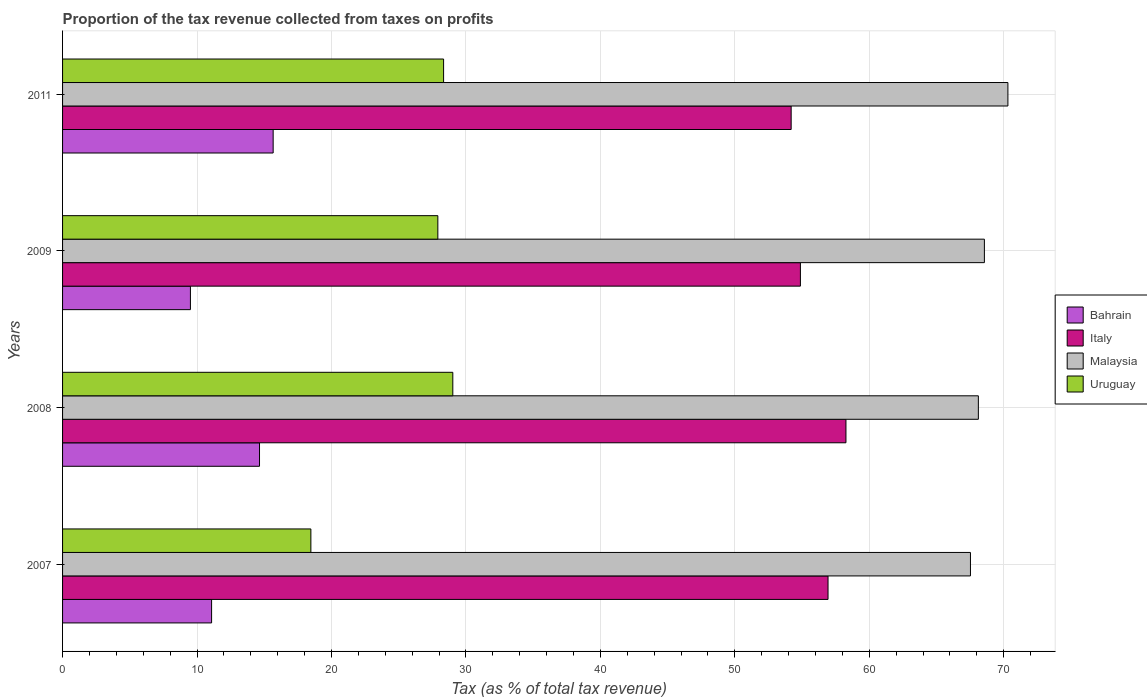How many different coloured bars are there?
Offer a very short reply. 4. What is the label of the 3rd group of bars from the top?
Offer a terse response. 2008. In how many cases, is the number of bars for a given year not equal to the number of legend labels?
Provide a short and direct response. 0. What is the proportion of the tax revenue collected in Italy in 2011?
Offer a very short reply. 54.19. Across all years, what is the maximum proportion of the tax revenue collected in Malaysia?
Offer a terse response. 70.31. Across all years, what is the minimum proportion of the tax revenue collected in Uruguay?
Your response must be concise. 18.47. In which year was the proportion of the tax revenue collected in Italy maximum?
Ensure brevity in your answer.  2008. What is the total proportion of the tax revenue collected in Uruguay in the graph?
Keep it short and to the point. 103.74. What is the difference between the proportion of the tax revenue collected in Bahrain in 2007 and that in 2011?
Your answer should be compact. -4.58. What is the difference between the proportion of the tax revenue collected in Bahrain in 2011 and the proportion of the tax revenue collected in Italy in 2007?
Make the answer very short. -41.27. What is the average proportion of the tax revenue collected in Uruguay per year?
Provide a short and direct response. 25.94. In the year 2011, what is the difference between the proportion of the tax revenue collected in Uruguay and proportion of the tax revenue collected in Bahrain?
Give a very brief answer. 12.68. In how many years, is the proportion of the tax revenue collected in Uruguay greater than 16 %?
Your response must be concise. 4. What is the ratio of the proportion of the tax revenue collected in Italy in 2008 to that in 2009?
Keep it short and to the point. 1.06. Is the difference between the proportion of the tax revenue collected in Uruguay in 2007 and 2011 greater than the difference between the proportion of the tax revenue collected in Bahrain in 2007 and 2011?
Make the answer very short. No. What is the difference between the highest and the second highest proportion of the tax revenue collected in Malaysia?
Your response must be concise. 1.75. What is the difference between the highest and the lowest proportion of the tax revenue collected in Malaysia?
Your response must be concise. 2.79. What does the 2nd bar from the top in 2007 represents?
Provide a succinct answer. Malaysia. What does the 1st bar from the bottom in 2009 represents?
Your answer should be compact. Bahrain. Are all the bars in the graph horizontal?
Provide a short and direct response. Yes. How many years are there in the graph?
Offer a very short reply. 4. Does the graph contain any zero values?
Your answer should be very brief. No. Where does the legend appear in the graph?
Offer a terse response. Center right. How many legend labels are there?
Offer a terse response. 4. What is the title of the graph?
Offer a terse response. Proportion of the tax revenue collected from taxes on profits. What is the label or title of the X-axis?
Provide a succinct answer. Tax (as % of total tax revenue). What is the Tax (as % of total tax revenue) in Bahrain in 2007?
Your answer should be compact. 11.08. What is the Tax (as % of total tax revenue) in Italy in 2007?
Your answer should be compact. 56.93. What is the Tax (as % of total tax revenue) of Malaysia in 2007?
Offer a very short reply. 67.53. What is the Tax (as % of total tax revenue) of Uruguay in 2007?
Keep it short and to the point. 18.47. What is the Tax (as % of total tax revenue) of Bahrain in 2008?
Ensure brevity in your answer.  14.65. What is the Tax (as % of total tax revenue) in Italy in 2008?
Your response must be concise. 58.27. What is the Tax (as % of total tax revenue) in Malaysia in 2008?
Your answer should be very brief. 68.11. What is the Tax (as % of total tax revenue) of Uruguay in 2008?
Keep it short and to the point. 29.02. What is the Tax (as % of total tax revenue) of Bahrain in 2009?
Your response must be concise. 9.51. What is the Tax (as % of total tax revenue) in Italy in 2009?
Give a very brief answer. 54.88. What is the Tax (as % of total tax revenue) in Malaysia in 2009?
Your answer should be very brief. 68.56. What is the Tax (as % of total tax revenue) in Uruguay in 2009?
Provide a succinct answer. 27.91. What is the Tax (as % of total tax revenue) of Bahrain in 2011?
Your answer should be compact. 15.66. What is the Tax (as % of total tax revenue) in Italy in 2011?
Keep it short and to the point. 54.19. What is the Tax (as % of total tax revenue) of Malaysia in 2011?
Offer a terse response. 70.31. What is the Tax (as % of total tax revenue) of Uruguay in 2011?
Make the answer very short. 28.34. Across all years, what is the maximum Tax (as % of total tax revenue) in Bahrain?
Your answer should be compact. 15.66. Across all years, what is the maximum Tax (as % of total tax revenue) in Italy?
Provide a succinct answer. 58.27. Across all years, what is the maximum Tax (as % of total tax revenue) of Malaysia?
Provide a succinct answer. 70.31. Across all years, what is the maximum Tax (as % of total tax revenue) of Uruguay?
Offer a very short reply. 29.02. Across all years, what is the minimum Tax (as % of total tax revenue) of Bahrain?
Your answer should be compact. 9.51. Across all years, what is the minimum Tax (as % of total tax revenue) in Italy?
Give a very brief answer. 54.19. Across all years, what is the minimum Tax (as % of total tax revenue) in Malaysia?
Provide a short and direct response. 67.53. Across all years, what is the minimum Tax (as % of total tax revenue) of Uruguay?
Give a very brief answer. 18.47. What is the total Tax (as % of total tax revenue) in Bahrain in the graph?
Your answer should be very brief. 50.9. What is the total Tax (as % of total tax revenue) of Italy in the graph?
Keep it short and to the point. 224.26. What is the total Tax (as % of total tax revenue) of Malaysia in the graph?
Offer a terse response. 274.51. What is the total Tax (as % of total tax revenue) of Uruguay in the graph?
Make the answer very short. 103.74. What is the difference between the Tax (as % of total tax revenue) in Bahrain in 2007 and that in 2008?
Your answer should be very brief. -3.56. What is the difference between the Tax (as % of total tax revenue) of Italy in 2007 and that in 2008?
Make the answer very short. -1.33. What is the difference between the Tax (as % of total tax revenue) of Malaysia in 2007 and that in 2008?
Provide a succinct answer. -0.59. What is the difference between the Tax (as % of total tax revenue) in Uruguay in 2007 and that in 2008?
Ensure brevity in your answer.  -10.56. What is the difference between the Tax (as % of total tax revenue) of Bahrain in 2007 and that in 2009?
Your answer should be very brief. 1.57. What is the difference between the Tax (as % of total tax revenue) in Italy in 2007 and that in 2009?
Give a very brief answer. 2.05. What is the difference between the Tax (as % of total tax revenue) of Malaysia in 2007 and that in 2009?
Provide a succinct answer. -1.04. What is the difference between the Tax (as % of total tax revenue) in Uruguay in 2007 and that in 2009?
Give a very brief answer. -9.44. What is the difference between the Tax (as % of total tax revenue) in Bahrain in 2007 and that in 2011?
Make the answer very short. -4.58. What is the difference between the Tax (as % of total tax revenue) of Italy in 2007 and that in 2011?
Provide a succinct answer. 2.74. What is the difference between the Tax (as % of total tax revenue) in Malaysia in 2007 and that in 2011?
Offer a very short reply. -2.79. What is the difference between the Tax (as % of total tax revenue) in Uruguay in 2007 and that in 2011?
Provide a short and direct response. -9.87. What is the difference between the Tax (as % of total tax revenue) of Bahrain in 2008 and that in 2009?
Keep it short and to the point. 5.14. What is the difference between the Tax (as % of total tax revenue) in Italy in 2008 and that in 2009?
Offer a very short reply. 3.39. What is the difference between the Tax (as % of total tax revenue) of Malaysia in 2008 and that in 2009?
Keep it short and to the point. -0.45. What is the difference between the Tax (as % of total tax revenue) of Uruguay in 2008 and that in 2009?
Give a very brief answer. 1.11. What is the difference between the Tax (as % of total tax revenue) of Bahrain in 2008 and that in 2011?
Offer a very short reply. -1.01. What is the difference between the Tax (as % of total tax revenue) of Italy in 2008 and that in 2011?
Ensure brevity in your answer.  4.08. What is the difference between the Tax (as % of total tax revenue) in Malaysia in 2008 and that in 2011?
Make the answer very short. -2.2. What is the difference between the Tax (as % of total tax revenue) of Uruguay in 2008 and that in 2011?
Keep it short and to the point. 0.69. What is the difference between the Tax (as % of total tax revenue) of Bahrain in 2009 and that in 2011?
Offer a terse response. -6.15. What is the difference between the Tax (as % of total tax revenue) of Italy in 2009 and that in 2011?
Give a very brief answer. 0.69. What is the difference between the Tax (as % of total tax revenue) in Malaysia in 2009 and that in 2011?
Keep it short and to the point. -1.75. What is the difference between the Tax (as % of total tax revenue) of Uruguay in 2009 and that in 2011?
Provide a succinct answer. -0.43. What is the difference between the Tax (as % of total tax revenue) of Bahrain in 2007 and the Tax (as % of total tax revenue) of Italy in 2008?
Keep it short and to the point. -47.18. What is the difference between the Tax (as % of total tax revenue) in Bahrain in 2007 and the Tax (as % of total tax revenue) in Malaysia in 2008?
Ensure brevity in your answer.  -57.03. What is the difference between the Tax (as % of total tax revenue) in Bahrain in 2007 and the Tax (as % of total tax revenue) in Uruguay in 2008?
Your response must be concise. -17.94. What is the difference between the Tax (as % of total tax revenue) of Italy in 2007 and the Tax (as % of total tax revenue) of Malaysia in 2008?
Give a very brief answer. -11.18. What is the difference between the Tax (as % of total tax revenue) in Italy in 2007 and the Tax (as % of total tax revenue) in Uruguay in 2008?
Offer a very short reply. 27.91. What is the difference between the Tax (as % of total tax revenue) of Malaysia in 2007 and the Tax (as % of total tax revenue) of Uruguay in 2008?
Provide a succinct answer. 38.5. What is the difference between the Tax (as % of total tax revenue) in Bahrain in 2007 and the Tax (as % of total tax revenue) in Italy in 2009?
Give a very brief answer. -43.79. What is the difference between the Tax (as % of total tax revenue) in Bahrain in 2007 and the Tax (as % of total tax revenue) in Malaysia in 2009?
Provide a succinct answer. -57.48. What is the difference between the Tax (as % of total tax revenue) of Bahrain in 2007 and the Tax (as % of total tax revenue) of Uruguay in 2009?
Your response must be concise. -16.83. What is the difference between the Tax (as % of total tax revenue) in Italy in 2007 and the Tax (as % of total tax revenue) in Malaysia in 2009?
Your answer should be very brief. -11.63. What is the difference between the Tax (as % of total tax revenue) in Italy in 2007 and the Tax (as % of total tax revenue) in Uruguay in 2009?
Ensure brevity in your answer.  29.02. What is the difference between the Tax (as % of total tax revenue) of Malaysia in 2007 and the Tax (as % of total tax revenue) of Uruguay in 2009?
Provide a short and direct response. 39.61. What is the difference between the Tax (as % of total tax revenue) in Bahrain in 2007 and the Tax (as % of total tax revenue) in Italy in 2011?
Make the answer very short. -43.11. What is the difference between the Tax (as % of total tax revenue) of Bahrain in 2007 and the Tax (as % of total tax revenue) of Malaysia in 2011?
Give a very brief answer. -59.23. What is the difference between the Tax (as % of total tax revenue) in Bahrain in 2007 and the Tax (as % of total tax revenue) in Uruguay in 2011?
Give a very brief answer. -17.26. What is the difference between the Tax (as % of total tax revenue) of Italy in 2007 and the Tax (as % of total tax revenue) of Malaysia in 2011?
Provide a succinct answer. -13.38. What is the difference between the Tax (as % of total tax revenue) of Italy in 2007 and the Tax (as % of total tax revenue) of Uruguay in 2011?
Offer a terse response. 28.59. What is the difference between the Tax (as % of total tax revenue) of Malaysia in 2007 and the Tax (as % of total tax revenue) of Uruguay in 2011?
Offer a very short reply. 39.19. What is the difference between the Tax (as % of total tax revenue) in Bahrain in 2008 and the Tax (as % of total tax revenue) in Italy in 2009?
Provide a succinct answer. -40.23. What is the difference between the Tax (as % of total tax revenue) of Bahrain in 2008 and the Tax (as % of total tax revenue) of Malaysia in 2009?
Offer a terse response. -53.91. What is the difference between the Tax (as % of total tax revenue) in Bahrain in 2008 and the Tax (as % of total tax revenue) in Uruguay in 2009?
Your response must be concise. -13.26. What is the difference between the Tax (as % of total tax revenue) of Italy in 2008 and the Tax (as % of total tax revenue) of Malaysia in 2009?
Provide a short and direct response. -10.3. What is the difference between the Tax (as % of total tax revenue) of Italy in 2008 and the Tax (as % of total tax revenue) of Uruguay in 2009?
Your answer should be compact. 30.35. What is the difference between the Tax (as % of total tax revenue) in Malaysia in 2008 and the Tax (as % of total tax revenue) in Uruguay in 2009?
Give a very brief answer. 40.2. What is the difference between the Tax (as % of total tax revenue) of Bahrain in 2008 and the Tax (as % of total tax revenue) of Italy in 2011?
Make the answer very short. -39.54. What is the difference between the Tax (as % of total tax revenue) in Bahrain in 2008 and the Tax (as % of total tax revenue) in Malaysia in 2011?
Give a very brief answer. -55.66. What is the difference between the Tax (as % of total tax revenue) in Bahrain in 2008 and the Tax (as % of total tax revenue) in Uruguay in 2011?
Ensure brevity in your answer.  -13.69. What is the difference between the Tax (as % of total tax revenue) in Italy in 2008 and the Tax (as % of total tax revenue) in Malaysia in 2011?
Provide a succinct answer. -12.05. What is the difference between the Tax (as % of total tax revenue) in Italy in 2008 and the Tax (as % of total tax revenue) in Uruguay in 2011?
Ensure brevity in your answer.  29.93. What is the difference between the Tax (as % of total tax revenue) in Malaysia in 2008 and the Tax (as % of total tax revenue) in Uruguay in 2011?
Make the answer very short. 39.77. What is the difference between the Tax (as % of total tax revenue) in Bahrain in 2009 and the Tax (as % of total tax revenue) in Italy in 2011?
Provide a succinct answer. -44.68. What is the difference between the Tax (as % of total tax revenue) of Bahrain in 2009 and the Tax (as % of total tax revenue) of Malaysia in 2011?
Your answer should be very brief. -60.8. What is the difference between the Tax (as % of total tax revenue) of Bahrain in 2009 and the Tax (as % of total tax revenue) of Uruguay in 2011?
Provide a succinct answer. -18.83. What is the difference between the Tax (as % of total tax revenue) of Italy in 2009 and the Tax (as % of total tax revenue) of Malaysia in 2011?
Provide a succinct answer. -15.43. What is the difference between the Tax (as % of total tax revenue) in Italy in 2009 and the Tax (as % of total tax revenue) in Uruguay in 2011?
Make the answer very short. 26.54. What is the difference between the Tax (as % of total tax revenue) of Malaysia in 2009 and the Tax (as % of total tax revenue) of Uruguay in 2011?
Your answer should be compact. 40.22. What is the average Tax (as % of total tax revenue) of Bahrain per year?
Make the answer very short. 12.73. What is the average Tax (as % of total tax revenue) of Italy per year?
Your answer should be compact. 56.07. What is the average Tax (as % of total tax revenue) of Malaysia per year?
Provide a succinct answer. 68.63. What is the average Tax (as % of total tax revenue) in Uruguay per year?
Provide a succinct answer. 25.94. In the year 2007, what is the difference between the Tax (as % of total tax revenue) of Bahrain and Tax (as % of total tax revenue) of Italy?
Keep it short and to the point. -45.85. In the year 2007, what is the difference between the Tax (as % of total tax revenue) of Bahrain and Tax (as % of total tax revenue) of Malaysia?
Ensure brevity in your answer.  -56.44. In the year 2007, what is the difference between the Tax (as % of total tax revenue) of Bahrain and Tax (as % of total tax revenue) of Uruguay?
Keep it short and to the point. -7.38. In the year 2007, what is the difference between the Tax (as % of total tax revenue) of Italy and Tax (as % of total tax revenue) of Malaysia?
Give a very brief answer. -10.59. In the year 2007, what is the difference between the Tax (as % of total tax revenue) of Italy and Tax (as % of total tax revenue) of Uruguay?
Provide a succinct answer. 38.46. In the year 2007, what is the difference between the Tax (as % of total tax revenue) in Malaysia and Tax (as % of total tax revenue) in Uruguay?
Provide a short and direct response. 49.06. In the year 2008, what is the difference between the Tax (as % of total tax revenue) in Bahrain and Tax (as % of total tax revenue) in Italy?
Provide a succinct answer. -43.62. In the year 2008, what is the difference between the Tax (as % of total tax revenue) in Bahrain and Tax (as % of total tax revenue) in Malaysia?
Your answer should be compact. -53.47. In the year 2008, what is the difference between the Tax (as % of total tax revenue) of Bahrain and Tax (as % of total tax revenue) of Uruguay?
Your answer should be compact. -14.38. In the year 2008, what is the difference between the Tax (as % of total tax revenue) in Italy and Tax (as % of total tax revenue) in Malaysia?
Keep it short and to the point. -9.85. In the year 2008, what is the difference between the Tax (as % of total tax revenue) of Italy and Tax (as % of total tax revenue) of Uruguay?
Your answer should be compact. 29.24. In the year 2008, what is the difference between the Tax (as % of total tax revenue) in Malaysia and Tax (as % of total tax revenue) in Uruguay?
Provide a short and direct response. 39.09. In the year 2009, what is the difference between the Tax (as % of total tax revenue) in Bahrain and Tax (as % of total tax revenue) in Italy?
Give a very brief answer. -45.37. In the year 2009, what is the difference between the Tax (as % of total tax revenue) in Bahrain and Tax (as % of total tax revenue) in Malaysia?
Ensure brevity in your answer.  -59.05. In the year 2009, what is the difference between the Tax (as % of total tax revenue) in Bahrain and Tax (as % of total tax revenue) in Uruguay?
Give a very brief answer. -18.4. In the year 2009, what is the difference between the Tax (as % of total tax revenue) of Italy and Tax (as % of total tax revenue) of Malaysia?
Make the answer very short. -13.68. In the year 2009, what is the difference between the Tax (as % of total tax revenue) of Italy and Tax (as % of total tax revenue) of Uruguay?
Offer a very short reply. 26.97. In the year 2009, what is the difference between the Tax (as % of total tax revenue) in Malaysia and Tax (as % of total tax revenue) in Uruguay?
Ensure brevity in your answer.  40.65. In the year 2011, what is the difference between the Tax (as % of total tax revenue) in Bahrain and Tax (as % of total tax revenue) in Italy?
Offer a terse response. -38.53. In the year 2011, what is the difference between the Tax (as % of total tax revenue) in Bahrain and Tax (as % of total tax revenue) in Malaysia?
Ensure brevity in your answer.  -54.65. In the year 2011, what is the difference between the Tax (as % of total tax revenue) of Bahrain and Tax (as % of total tax revenue) of Uruguay?
Provide a succinct answer. -12.68. In the year 2011, what is the difference between the Tax (as % of total tax revenue) in Italy and Tax (as % of total tax revenue) in Malaysia?
Offer a very short reply. -16.12. In the year 2011, what is the difference between the Tax (as % of total tax revenue) of Italy and Tax (as % of total tax revenue) of Uruguay?
Provide a succinct answer. 25.85. In the year 2011, what is the difference between the Tax (as % of total tax revenue) in Malaysia and Tax (as % of total tax revenue) in Uruguay?
Your response must be concise. 41.97. What is the ratio of the Tax (as % of total tax revenue) in Bahrain in 2007 to that in 2008?
Give a very brief answer. 0.76. What is the ratio of the Tax (as % of total tax revenue) of Italy in 2007 to that in 2008?
Ensure brevity in your answer.  0.98. What is the ratio of the Tax (as % of total tax revenue) of Malaysia in 2007 to that in 2008?
Your response must be concise. 0.99. What is the ratio of the Tax (as % of total tax revenue) in Uruguay in 2007 to that in 2008?
Give a very brief answer. 0.64. What is the ratio of the Tax (as % of total tax revenue) of Bahrain in 2007 to that in 2009?
Your response must be concise. 1.17. What is the ratio of the Tax (as % of total tax revenue) of Italy in 2007 to that in 2009?
Your answer should be compact. 1.04. What is the ratio of the Tax (as % of total tax revenue) in Malaysia in 2007 to that in 2009?
Make the answer very short. 0.98. What is the ratio of the Tax (as % of total tax revenue) in Uruguay in 2007 to that in 2009?
Keep it short and to the point. 0.66. What is the ratio of the Tax (as % of total tax revenue) in Bahrain in 2007 to that in 2011?
Your answer should be compact. 0.71. What is the ratio of the Tax (as % of total tax revenue) in Italy in 2007 to that in 2011?
Your response must be concise. 1.05. What is the ratio of the Tax (as % of total tax revenue) of Malaysia in 2007 to that in 2011?
Your response must be concise. 0.96. What is the ratio of the Tax (as % of total tax revenue) in Uruguay in 2007 to that in 2011?
Make the answer very short. 0.65. What is the ratio of the Tax (as % of total tax revenue) in Bahrain in 2008 to that in 2009?
Give a very brief answer. 1.54. What is the ratio of the Tax (as % of total tax revenue) in Italy in 2008 to that in 2009?
Give a very brief answer. 1.06. What is the ratio of the Tax (as % of total tax revenue) in Uruguay in 2008 to that in 2009?
Make the answer very short. 1.04. What is the ratio of the Tax (as % of total tax revenue) of Bahrain in 2008 to that in 2011?
Ensure brevity in your answer.  0.94. What is the ratio of the Tax (as % of total tax revenue) in Italy in 2008 to that in 2011?
Provide a succinct answer. 1.08. What is the ratio of the Tax (as % of total tax revenue) of Malaysia in 2008 to that in 2011?
Give a very brief answer. 0.97. What is the ratio of the Tax (as % of total tax revenue) in Uruguay in 2008 to that in 2011?
Offer a terse response. 1.02. What is the ratio of the Tax (as % of total tax revenue) of Bahrain in 2009 to that in 2011?
Your answer should be very brief. 0.61. What is the ratio of the Tax (as % of total tax revenue) of Italy in 2009 to that in 2011?
Make the answer very short. 1.01. What is the ratio of the Tax (as % of total tax revenue) in Malaysia in 2009 to that in 2011?
Your response must be concise. 0.98. What is the ratio of the Tax (as % of total tax revenue) in Uruguay in 2009 to that in 2011?
Ensure brevity in your answer.  0.98. What is the difference between the highest and the second highest Tax (as % of total tax revenue) in Bahrain?
Provide a short and direct response. 1.01. What is the difference between the highest and the second highest Tax (as % of total tax revenue) in Malaysia?
Your answer should be very brief. 1.75. What is the difference between the highest and the second highest Tax (as % of total tax revenue) of Uruguay?
Your response must be concise. 0.69. What is the difference between the highest and the lowest Tax (as % of total tax revenue) in Bahrain?
Offer a terse response. 6.15. What is the difference between the highest and the lowest Tax (as % of total tax revenue) in Italy?
Keep it short and to the point. 4.08. What is the difference between the highest and the lowest Tax (as % of total tax revenue) in Malaysia?
Your answer should be compact. 2.79. What is the difference between the highest and the lowest Tax (as % of total tax revenue) in Uruguay?
Offer a terse response. 10.56. 